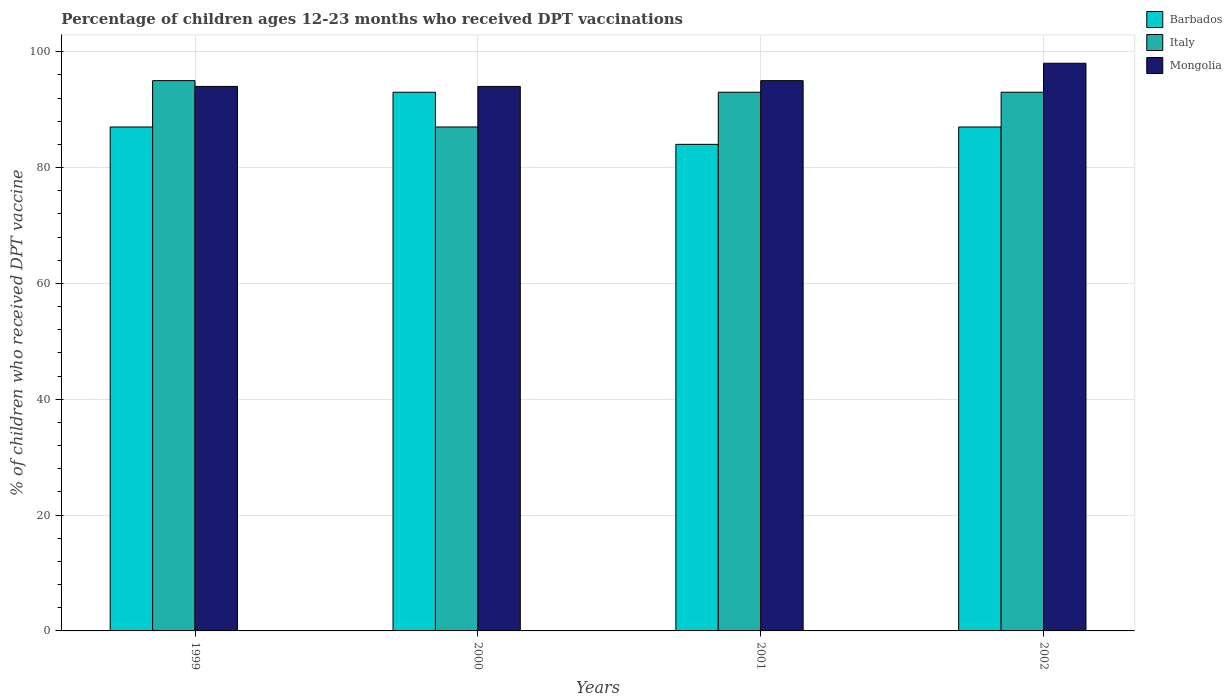Are the number of bars per tick equal to the number of legend labels?
Ensure brevity in your answer.  Yes. Are the number of bars on each tick of the X-axis equal?
Offer a terse response. Yes. How many bars are there on the 3rd tick from the left?
Ensure brevity in your answer.  3. In how many cases, is the number of bars for a given year not equal to the number of legend labels?
Offer a very short reply. 0. What is the percentage of children who received DPT vaccination in Italy in 2000?
Provide a short and direct response. 87. Across all years, what is the maximum percentage of children who received DPT vaccination in Italy?
Make the answer very short. 95. Across all years, what is the minimum percentage of children who received DPT vaccination in Barbados?
Offer a terse response. 84. In which year was the percentage of children who received DPT vaccination in Italy maximum?
Offer a very short reply. 1999. What is the total percentage of children who received DPT vaccination in Barbados in the graph?
Give a very brief answer. 351. What is the difference between the percentage of children who received DPT vaccination in Mongolia in 2000 and that in 2002?
Ensure brevity in your answer.  -4. What is the difference between the percentage of children who received DPT vaccination in Mongolia in 2000 and the percentage of children who received DPT vaccination in Italy in 2002?
Ensure brevity in your answer.  1. What is the average percentage of children who received DPT vaccination in Mongolia per year?
Give a very brief answer. 95.25. In the year 2000, what is the difference between the percentage of children who received DPT vaccination in Italy and percentage of children who received DPT vaccination in Barbados?
Give a very brief answer. -6. What is the ratio of the percentage of children who received DPT vaccination in Mongolia in 1999 to that in 2002?
Ensure brevity in your answer.  0.96. Is the percentage of children who received DPT vaccination in Mongolia in 1999 less than that in 2002?
Your response must be concise. Yes. What is the difference between the highest and the second highest percentage of children who received DPT vaccination in Barbados?
Give a very brief answer. 6. What is the difference between the highest and the lowest percentage of children who received DPT vaccination in Barbados?
Your answer should be very brief. 9. In how many years, is the percentage of children who received DPT vaccination in Mongolia greater than the average percentage of children who received DPT vaccination in Mongolia taken over all years?
Provide a succinct answer. 1. What does the 3rd bar from the left in 2002 represents?
Provide a succinct answer. Mongolia. What does the 3rd bar from the right in 2002 represents?
Your response must be concise. Barbados. How many bars are there?
Ensure brevity in your answer.  12. How many years are there in the graph?
Your response must be concise. 4. What is the difference between two consecutive major ticks on the Y-axis?
Make the answer very short. 20. Does the graph contain grids?
Your answer should be compact. Yes. Where does the legend appear in the graph?
Provide a succinct answer. Top right. How many legend labels are there?
Ensure brevity in your answer.  3. What is the title of the graph?
Offer a very short reply. Percentage of children ages 12-23 months who received DPT vaccinations. What is the label or title of the X-axis?
Ensure brevity in your answer.  Years. What is the label or title of the Y-axis?
Provide a succinct answer. % of children who received DPT vaccine. What is the % of children who received DPT vaccine in Mongolia in 1999?
Keep it short and to the point. 94. What is the % of children who received DPT vaccine of Barbados in 2000?
Make the answer very short. 93. What is the % of children who received DPT vaccine of Mongolia in 2000?
Give a very brief answer. 94. What is the % of children who received DPT vaccine in Italy in 2001?
Keep it short and to the point. 93. What is the % of children who received DPT vaccine of Italy in 2002?
Ensure brevity in your answer.  93. Across all years, what is the maximum % of children who received DPT vaccine of Barbados?
Your answer should be very brief. 93. Across all years, what is the minimum % of children who received DPT vaccine in Italy?
Give a very brief answer. 87. Across all years, what is the minimum % of children who received DPT vaccine in Mongolia?
Keep it short and to the point. 94. What is the total % of children who received DPT vaccine of Barbados in the graph?
Offer a very short reply. 351. What is the total % of children who received DPT vaccine in Italy in the graph?
Your response must be concise. 368. What is the total % of children who received DPT vaccine of Mongolia in the graph?
Provide a succinct answer. 381. What is the difference between the % of children who received DPT vaccine in Barbados in 1999 and that in 2000?
Make the answer very short. -6. What is the difference between the % of children who received DPT vaccine in Barbados in 1999 and that in 2001?
Offer a terse response. 3. What is the difference between the % of children who received DPT vaccine in Italy in 1999 and that in 2001?
Provide a succinct answer. 2. What is the difference between the % of children who received DPT vaccine in Barbados in 1999 and that in 2002?
Offer a terse response. 0. What is the difference between the % of children who received DPT vaccine of Italy in 1999 and that in 2002?
Provide a short and direct response. 2. What is the difference between the % of children who received DPT vaccine in Barbados in 2000 and that in 2001?
Offer a terse response. 9. What is the difference between the % of children who received DPT vaccine of Barbados in 2000 and that in 2002?
Your answer should be very brief. 6. What is the difference between the % of children who received DPT vaccine in Italy in 2000 and that in 2002?
Offer a very short reply. -6. What is the difference between the % of children who received DPT vaccine of Mongolia in 2001 and that in 2002?
Provide a short and direct response. -3. What is the difference between the % of children who received DPT vaccine in Barbados in 1999 and the % of children who received DPT vaccine in Italy in 2000?
Offer a terse response. 0. What is the difference between the % of children who received DPT vaccine in Barbados in 1999 and the % of children who received DPT vaccine in Mongolia in 2000?
Offer a very short reply. -7. What is the difference between the % of children who received DPT vaccine in Italy in 1999 and the % of children who received DPT vaccine in Mongolia in 2000?
Provide a succinct answer. 1. What is the difference between the % of children who received DPT vaccine of Barbados in 1999 and the % of children who received DPT vaccine of Italy in 2001?
Provide a succinct answer. -6. What is the difference between the % of children who received DPT vaccine in Barbados in 1999 and the % of children who received DPT vaccine in Mongolia in 2001?
Offer a very short reply. -8. What is the difference between the % of children who received DPT vaccine of Barbados in 1999 and the % of children who received DPT vaccine of Italy in 2002?
Your answer should be very brief. -6. What is the difference between the % of children who received DPT vaccine in Barbados in 1999 and the % of children who received DPT vaccine in Mongolia in 2002?
Your answer should be compact. -11. What is the difference between the % of children who received DPT vaccine of Italy in 2000 and the % of children who received DPT vaccine of Mongolia in 2001?
Provide a short and direct response. -8. What is the difference between the % of children who received DPT vaccine of Barbados in 2000 and the % of children who received DPT vaccine of Mongolia in 2002?
Your response must be concise. -5. What is the difference between the % of children who received DPT vaccine in Italy in 2000 and the % of children who received DPT vaccine in Mongolia in 2002?
Offer a terse response. -11. What is the difference between the % of children who received DPT vaccine in Barbados in 2001 and the % of children who received DPT vaccine in Italy in 2002?
Your answer should be very brief. -9. What is the difference between the % of children who received DPT vaccine of Italy in 2001 and the % of children who received DPT vaccine of Mongolia in 2002?
Your answer should be compact. -5. What is the average % of children who received DPT vaccine of Barbados per year?
Offer a terse response. 87.75. What is the average % of children who received DPT vaccine of Italy per year?
Make the answer very short. 92. What is the average % of children who received DPT vaccine of Mongolia per year?
Your response must be concise. 95.25. In the year 1999, what is the difference between the % of children who received DPT vaccine of Barbados and % of children who received DPT vaccine of Italy?
Your answer should be compact. -8. In the year 1999, what is the difference between the % of children who received DPT vaccine of Italy and % of children who received DPT vaccine of Mongolia?
Give a very brief answer. 1. In the year 2000, what is the difference between the % of children who received DPT vaccine in Barbados and % of children who received DPT vaccine in Mongolia?
Keep it short and to the point. -1. In the year 2001, what is the difference between the % of children who received DPT vaccine of Barbados and % of children who received DPT vaccine of Mongolia?
Make the answer very short. -11. In the year 2001, what is the difference between the % of children who received DPT vaccine in Italy and % of children who received DPT vaccine in Mongolia?
Provide a succinct answer. -2. In the year 2002, what is the difference between the % of children who received DPT vaccine in Italy and % of children who received DPT vaccine in Mongolia?
Ensure brevity in your answer.  -5. What is the ratio of the % of children who received DPT vaccine of Barbados in 1999 to that in 2000?
Give a very brief answer. 0.94. What is the ratio of the % of children who received DPT vaccine in Italy in 1999 to that in 2000?
Provide a succinct answer. 1.09. What is the ratio of the % of children who received DPT vaccine of Mongolia in 1999 to that in 2000?
Offer a terse response. 1. What is the ratio of the % of children who received DPT vaccine of Barbados in 1999 to that in 2001?
Ensure brevity in your answer.  1.04. What is the ratio of the % of children who received DPT vaccine of Italy in 1999 to that in 2001?
Your answer should be very brief. 1.02. What is the ratio of the % of children who received DPT vaccine in Mongolia in 1999 to that in 2001?
Provide a succinct answer. 0.99. What is the ratio of the % of children who received DPT vaccine in Italy in 1999 to that in 2002?
Provide a short and direct response. 1.02. What is the ratio of the % of children who received DPT vaccine of Mongolia in 1999 to that in 2002?
Your answer should be very brief. 0.96. What is the ratio of the % of children who received DPT vaccine of Barbados in 2000 to that in 2001?
Provide a short and direct response. 1.11. What is the ratio of the % of children who received DPT vaccine in Italy in 2000 to that in 2001?
Your answer should be very brief. 0.94. What is the ratio of the % of children who received DPT vaccine of Mongolia in 2000 to that in 2001?
Offer a terse response. 0.99. What is the ratio of the % of children who received DPT vaccine in Barbados in 2000 to that in 2002?
Your answer should be compact. 1.07. What is the ratio of the % of children who received DPT vaccine of Italy in 2000 to that in 2002?
Make the answer very short. 0.94. What is the ratio of the % of children who received DPT vaccine in Mongolia in 2000 to that in 2002?
Give a very brief answer. 0.96. What is the ratio of the % of children who received DPT vaccine of Barbados in 2001 to that in 2002?
Offer a very short reply. 0.97. What is the ratio of the % of children who received DPT vaccine of Mongolia in 2001 to that in 2002?
Provide a short and direct response. 0.97. What is the difference between the highest and the second highest % of children who received DPT vaccine in Italy?
Your answer should be very brief. 2. What is the difference between the highest and the lowest % of children who received DPT vaccine in Barbados?
Give a very brief answer. 9. What is the difference between the highest and the lowest % of children who received DPT vaccine of Italy?
Give a very brief answer. 8. 